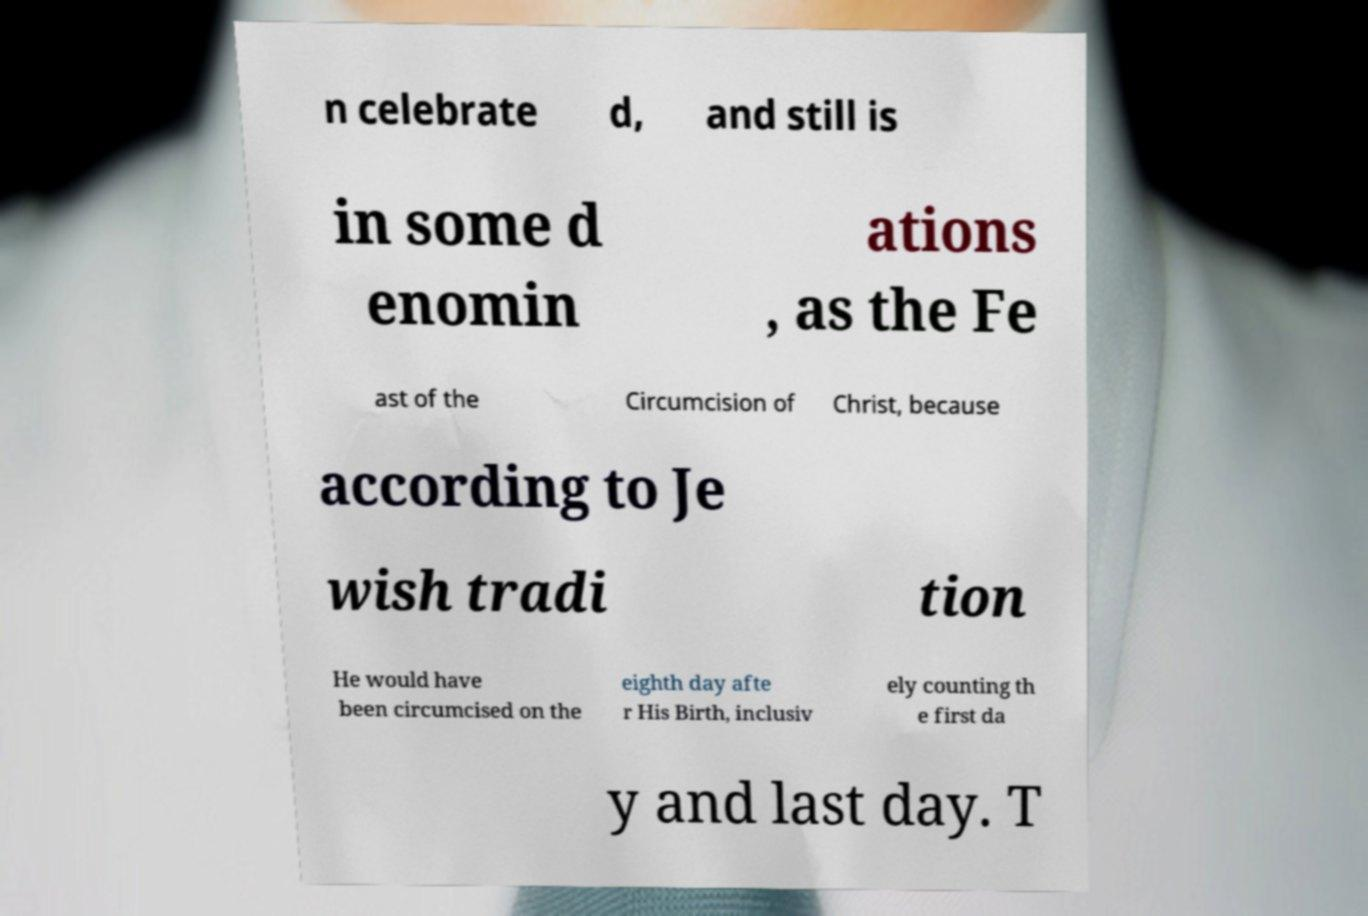Please read and relay the text visible in this image. What does it say? n celebrate d, and still is in some d enomin ations , as the Fe ast of the Circumcision of Christ, because according to Je wish tradi tion He would have been circumcised on the eighth day afte r His Birth, inclusiv ely counting th e first da y and last day. T 